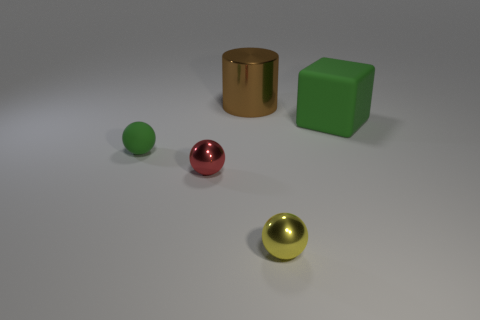Can you describe the lighting in this scene? The lighting in this scene appears soft and diffused, illuminating the objects from above and creating gentle shadows beneath them. This could indicate an indoor setting with ambient lighting, potentially from overhead light sources. How does the lighting affect the appearance of the objects? The diffused lighting accentuates the shapes of the objects by casting soft-edged shadows and giving them a 3D form. It also highlights the textures, revealing the reflective qualities of the metallic materials and the matte finish of the green cube. 